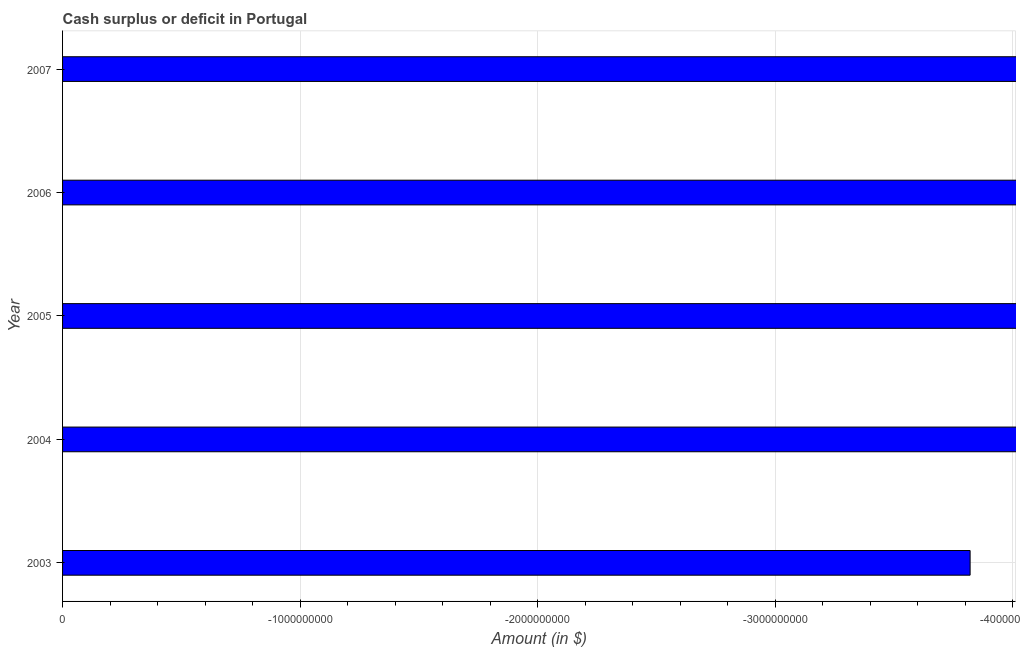Does the graph contain grids?
Keep it short and to the point. Yes. What is the title of the graph?
Offer a very short reply. Cash surplus or deficit in Portugal. What is the label or title of the X-axis?
Your response must be concise. Amount (in $). Across all years, what is the minimum cash surplus or deficit?
Offer a terse response. 0. What is the median cash surplus or deficit?
Offer a very short reply. 0. In how many years, is the cash surplus or deficit greater than -400000000 $?
Provide a succinct answer. 0. Are all the bars in the graph horizontal?
Offer a very short reply. Yes. What is the Amount (in $) of 2003?
Your response must be concise. 0. What is the Amount (in $) of 2004?
Offer a very short reply. 0. What is the Amount (in $) of 2005?
Your response must be concise. 0. What is the Amount (in $) of 2007?
Provide a succinct answer. 0. 